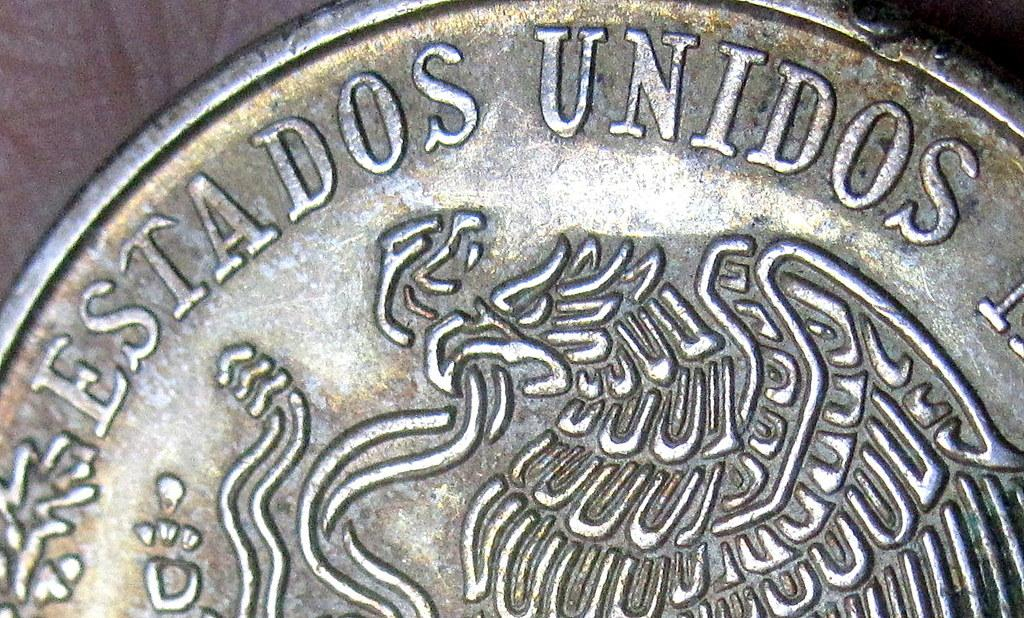<image>
Describe the image concisely. a coin labeled 'estados unidos' and that has an eagle on it 